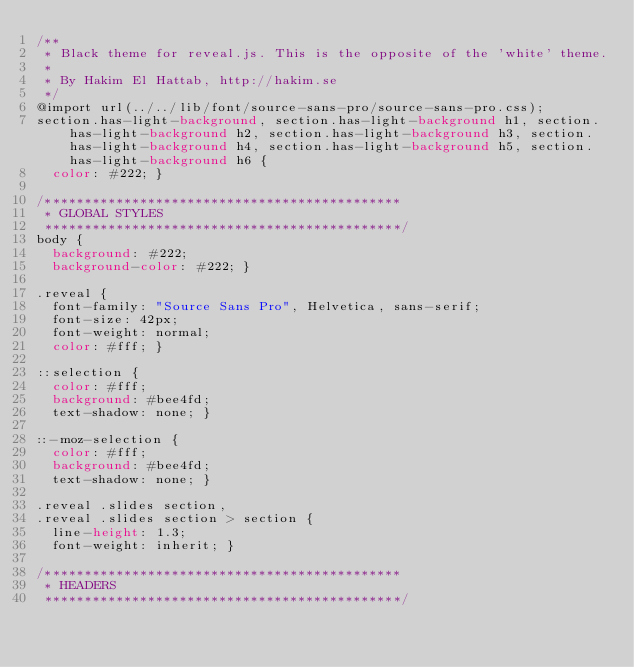<code> <loc_0><loc_0><loc_500><loc_500><_CSS_>/**
 * Black theme for reveal.js. This is the opposite of the 'white' theme.
 *
 * By Hakim El Hattab, http://hakim.se
 */
@import url(../../lib/font/source-sans-pro/source-sans-pro.css);
section.has-light-background, section.has-light-background h1, section.has-light-background h2, section.has-light-background h3, section.has-light-background h4, section.has-light-background h5, section.has-light-background h6 {
  color: #222; }

/*********************************************
 * GLOBAL STYLES
 *********************************************/
body {
  background: #222;
  background-color: #222; }

.reveal {
  font-family: "Source Sans Pro", Helvetica, sans-serif;
  font-size: 42px;
  font-weight: normal;
  color: #fff; }

::selection {
  color: #fff;
  background: #bee4fd;
  text-shadow: none; }

::-moz-selection {
  color: #fff;
  background: #bee4fd;
  text-shadow: none; }

.reveal .slides section,
.reveal .slides section > section {
  line-height: 1.3;
  font-weight: inherit; }

/*********************************************
 * HEADERS
 *********************************************/</code> 